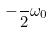Convert formula to latex. <formula><loc_0><loc_0><loc_500><loc_500>- \frac { } { 2 } \omega _ { 0 }</formula> 